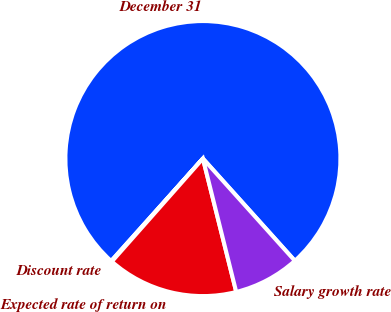Convert chart to OTSL. <chart><loc_0><loc_0><loc_500><loc_500><pie_chart><fcel>December 31<fcel>Discount rate<fcel>Expected rate of return on<fcel>Salary growth rate<nl><fcel>76.71%<fcel>0.1%<fcel>15.42%<fcel>7.76%<nl></chart> 